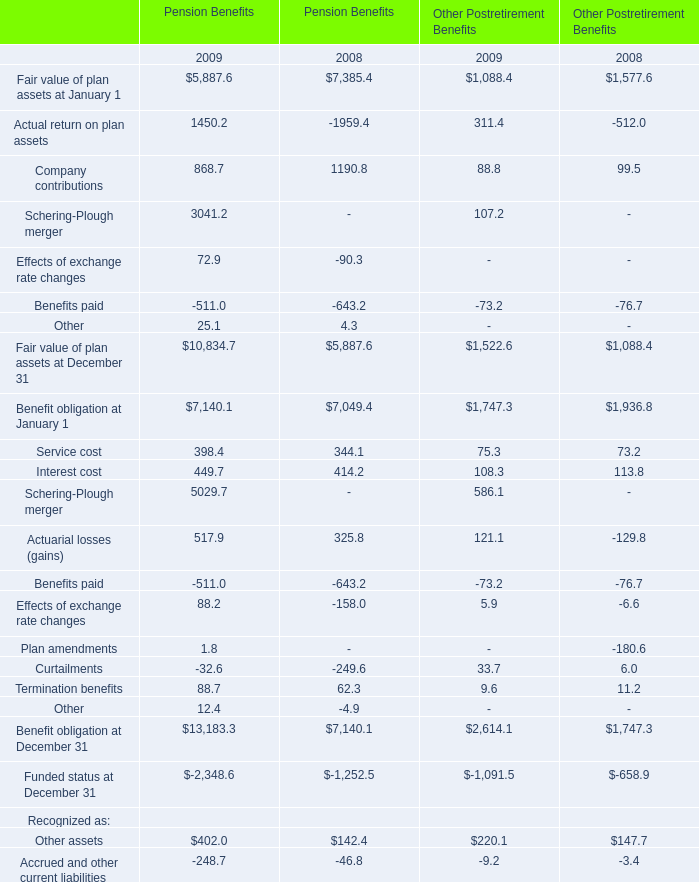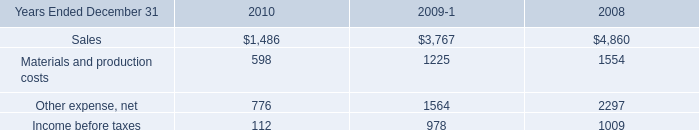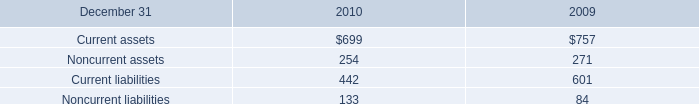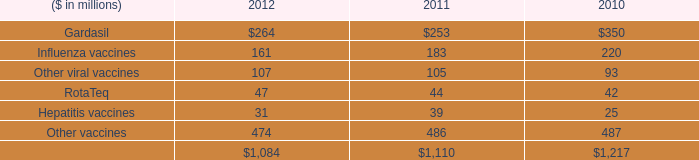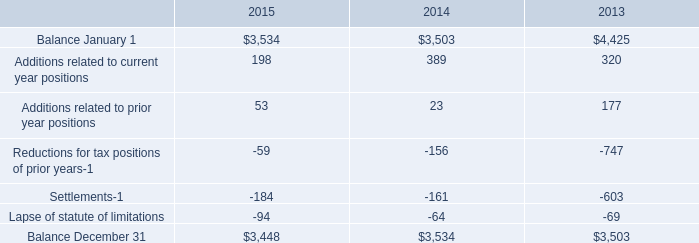What is the average amount of Benefit obligation at December 31 of Pension Benefits 2008, and Balance December 31 of 2014 ? 
Computations: ((7140.1 + 3534.0) / 2)
Answer: 5337.05. 